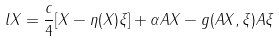Convert formula to latex. <formula><loc_0><loc_0><loc_500><loc_500>l X = \frac { c } { 4 } [ X - \eta ( X ) \xi ] + \alpha A X - g ( A X , \xi ) A \xi</formula> 